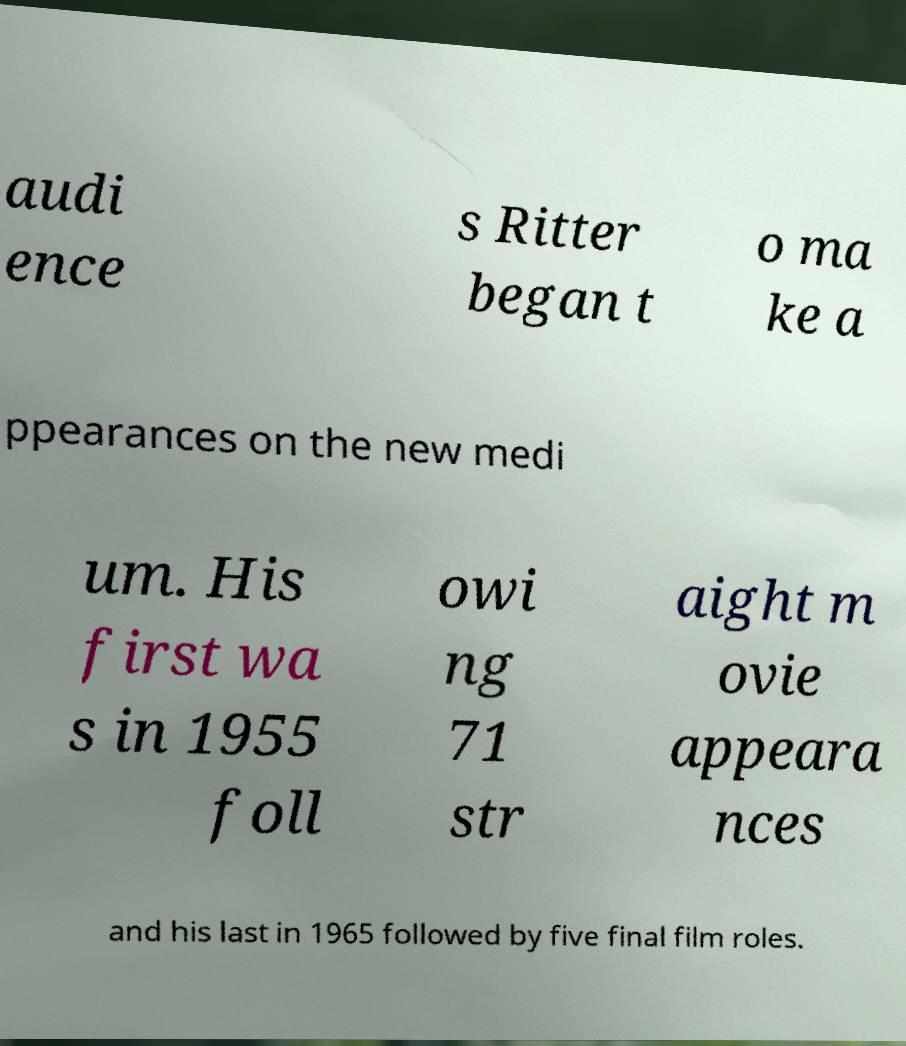There's text embedded in this image that I need extracted. Can you transcribe it verbatim? audi ence s Ritter began t o ma ke a ppearances on the new medi um. His first wa s in 1955 foll owi ng 71 str aight m ovie appeara nces and his last in 1965 followed by five final film roles. 